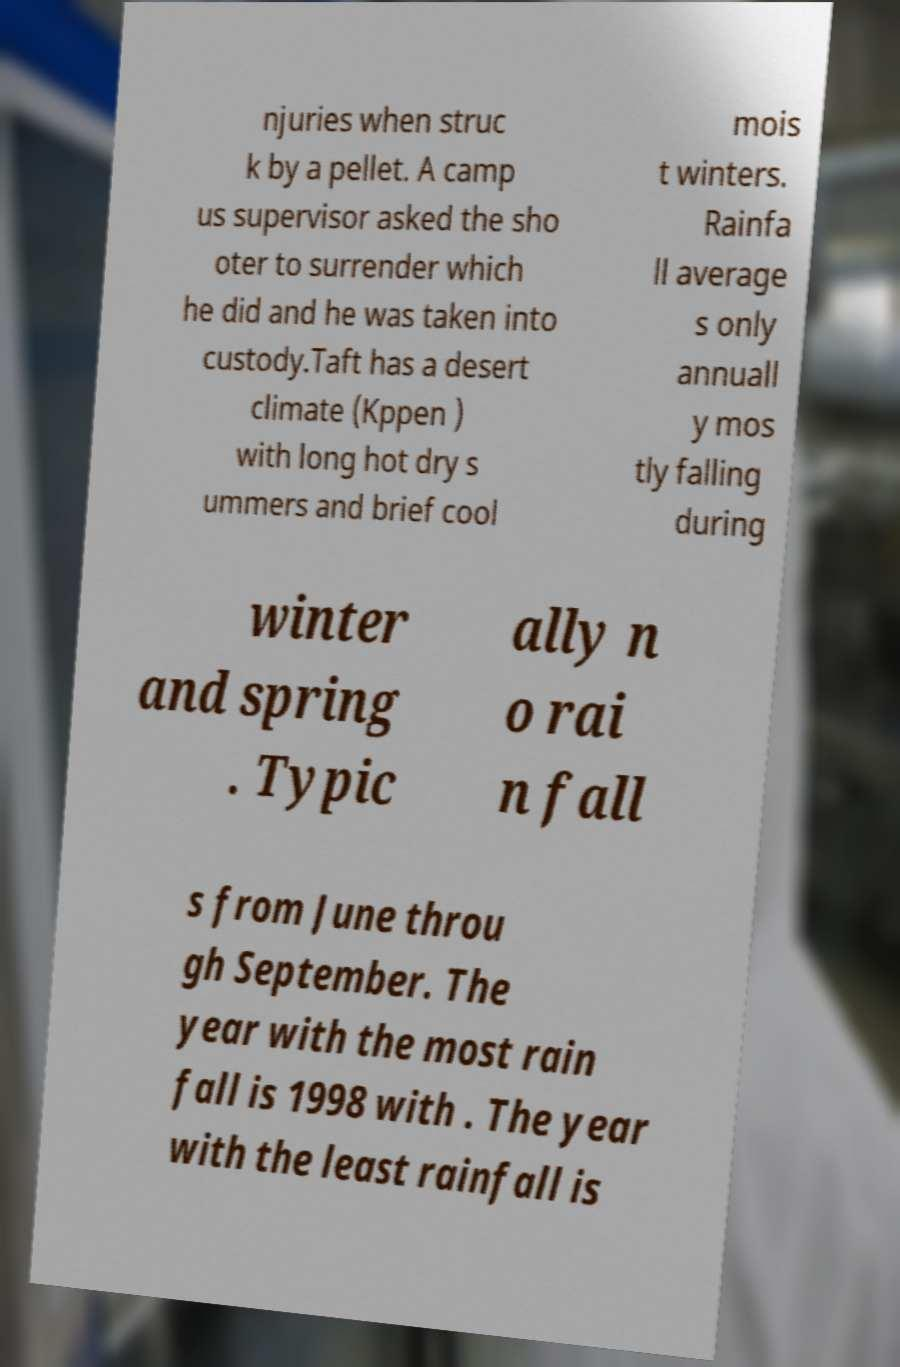What messages or text are displayed in this image? I need them in a readable, typed format. njuries when struc k by a pellet. A camp us supervisor asked the sho oter to surrender which he did and he was taken into custody.Taft has a desert climate (Kppen ) with long hot dry s ummers and brief cool mois t winters. Rainfa ll average s only annuall y mos tly falling during winter and spring . Typic ally n o rai n fall s from June throu gh September. The year with the most rain fall is 1998 with . The year with the least rainfall is 